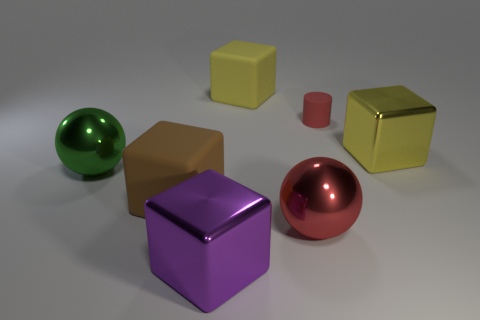There is a brown thing that is the same material as the cylinder; what shape is it? The brown object that shares the same material characteristics as the cylinder is in the shape of a cube. 